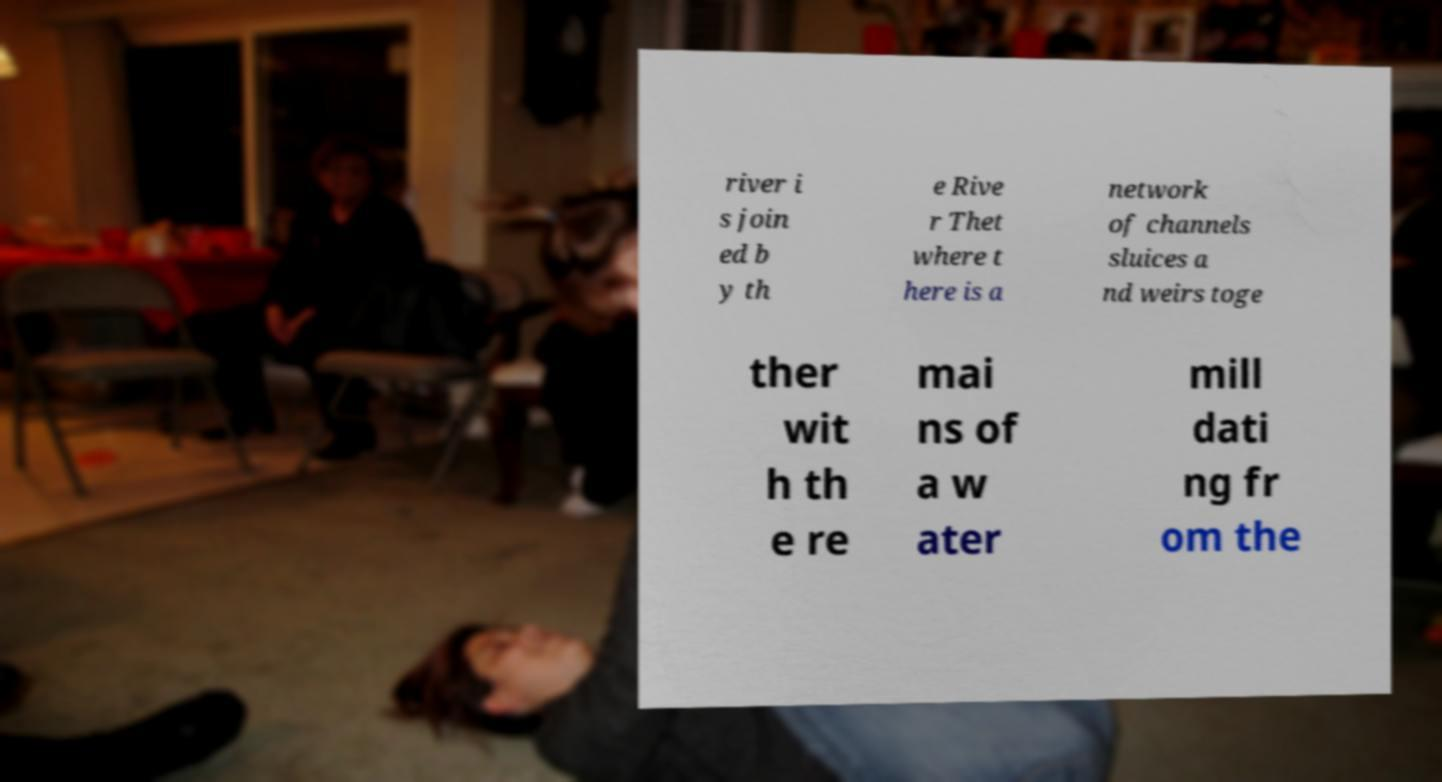Could you assist in decoding the text presented in this image and type it out clearly? river i s join ed b y th e Rive r Thet where t here is a network of channels sluices a nd weirs toge ther wit h th e re mai ns of a w ater mill dati ng fr om the 